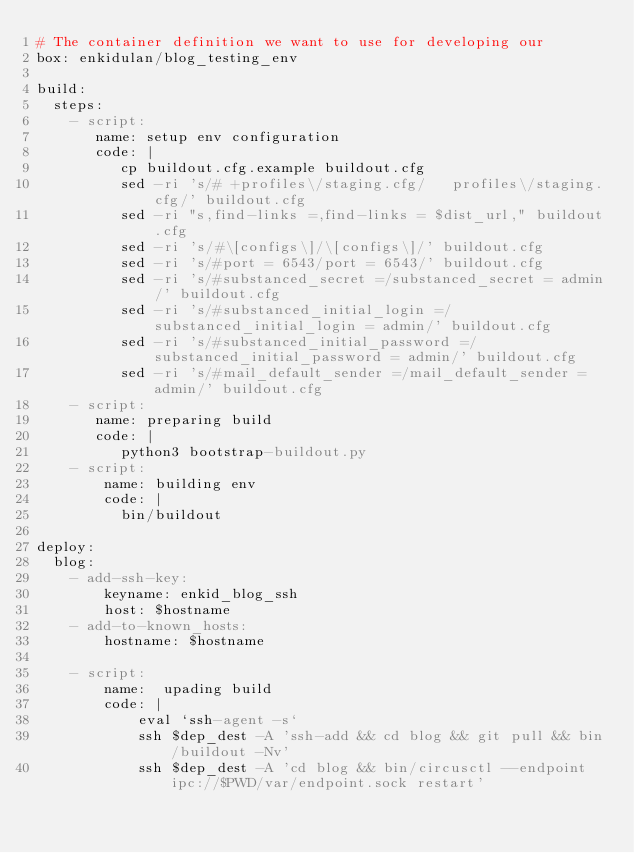Convert code to text. <code><loc_0><loc_0><loc_500><loc_500><_YAML_># The container definition we want to use for developing our
box: enkidulan/blog_testing_env

build:
  steps:
    - script:
       name: setup env configuration
       code: |
          cp buildout.cfg.example buildout.cfg
          sed -ri 's/# +profiles\/staging.cfg/   profiles\/staging.cfg/' buildout.cfg
          sed -ri "s,find-links =,find-links = $dist_url," buildout.cfg
          sed -ri 's/#\[configs\]/\[configs\]/' buildout.cfg
          sed -ri 's/#port = 6543/port = 6543/' buildout.cfg
          sed -ri 's/#substanced_secret =/substanced_secret = admin/' buildout.cfg
          sed -ri 's/#substanced_initial_login =/substanced_initial_login = admin/' buildout.cfg
          sed -ri 's/#substanced_initial_password =/substanced_initial_password = admin/' buildout.cfg
          sed -ri 's/#mail_default_sender =/mail_default_sender = admin/' buildout.cfg
    - script:
       name: preparing build
       code: |
          python3 bootstrap-buildout.py
    - script:
        name: building env
        code: |
          bin/buildout

deploy:
  blog:
    - add-ssh-key:
        keyname: enkid_blog_ssh
        host: $hostname
    - add-to-known_hosts:
        hostname: $hostname

    - script:
        name:  upading build
        code: |
            eval `ssh-agent -s`
            ssh $dep_dest -A 'ssh-add && cd blog && git pull && bin/buildout -Nv'
            ssh $dep_dest -A 'cd blog && bin/circusctl --endpoint ipc://$PWD/var/endpoint.sock restart'
</code> 